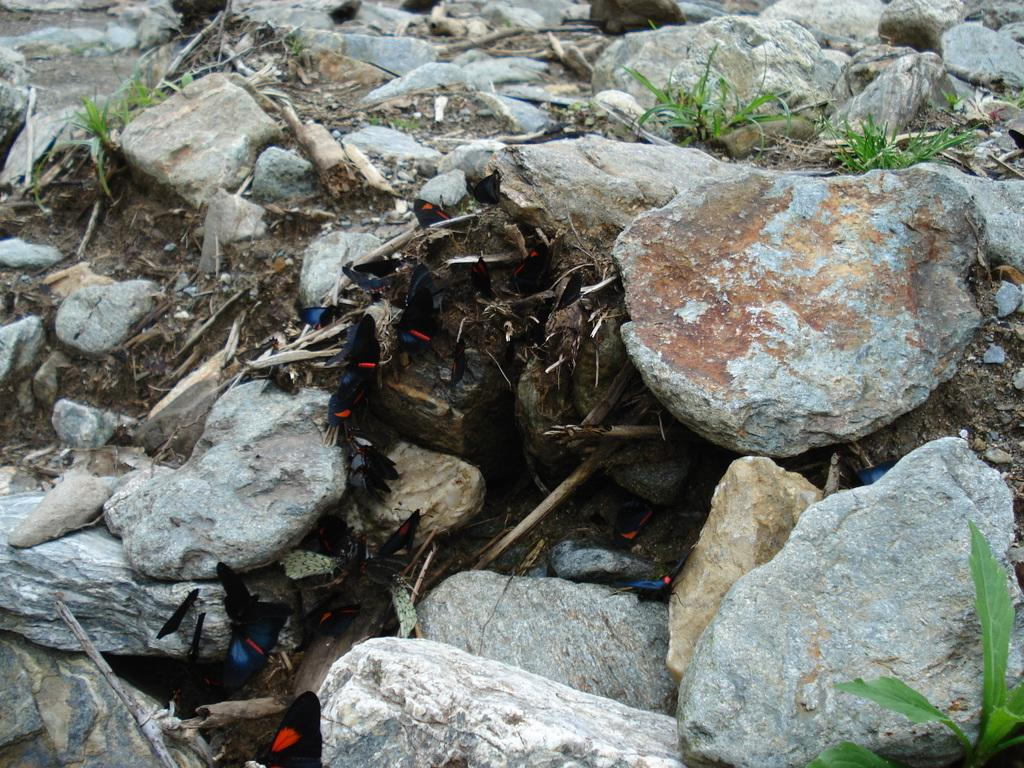What is the primary feature of the image? The primary feature of the image is the many stones. Are there any living organisms visible in the image? Yes, there are butterflies in the middle of the image. What else can be seen on the ground in the image? A: There are few plants on the ground in the image. What type of skin treatment is being applied to the stones in the image? There is no skin treatment being applied to the stones in the image; the image only shows stones, butterflies, and plants. 